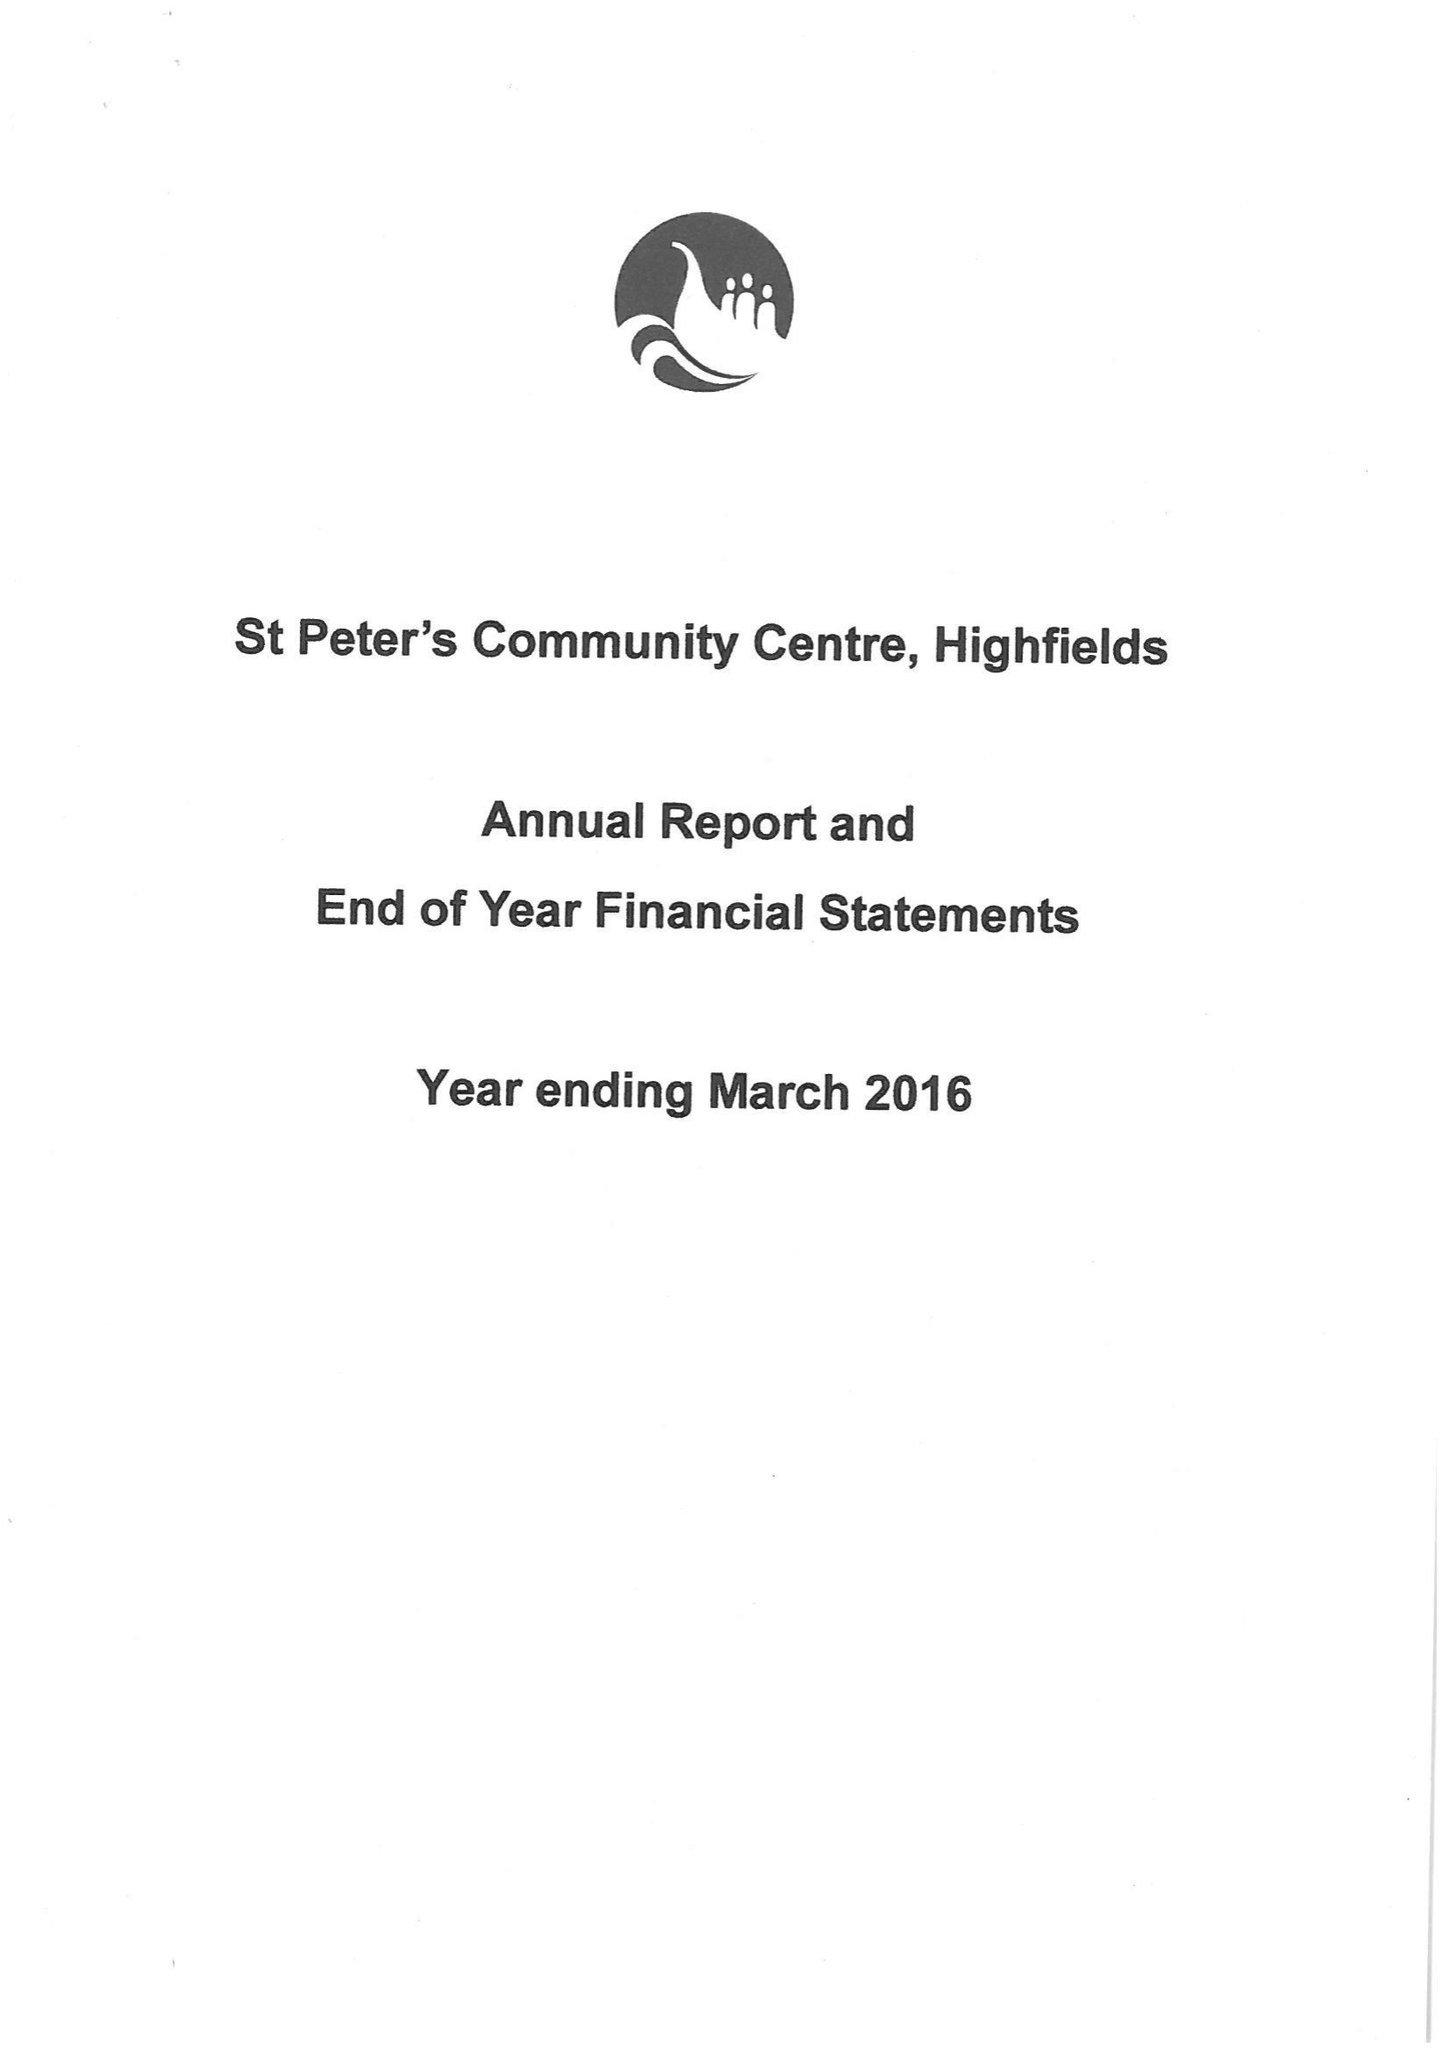What is the value for the address__post_town?
Answer the question using a single word or phrase. None 